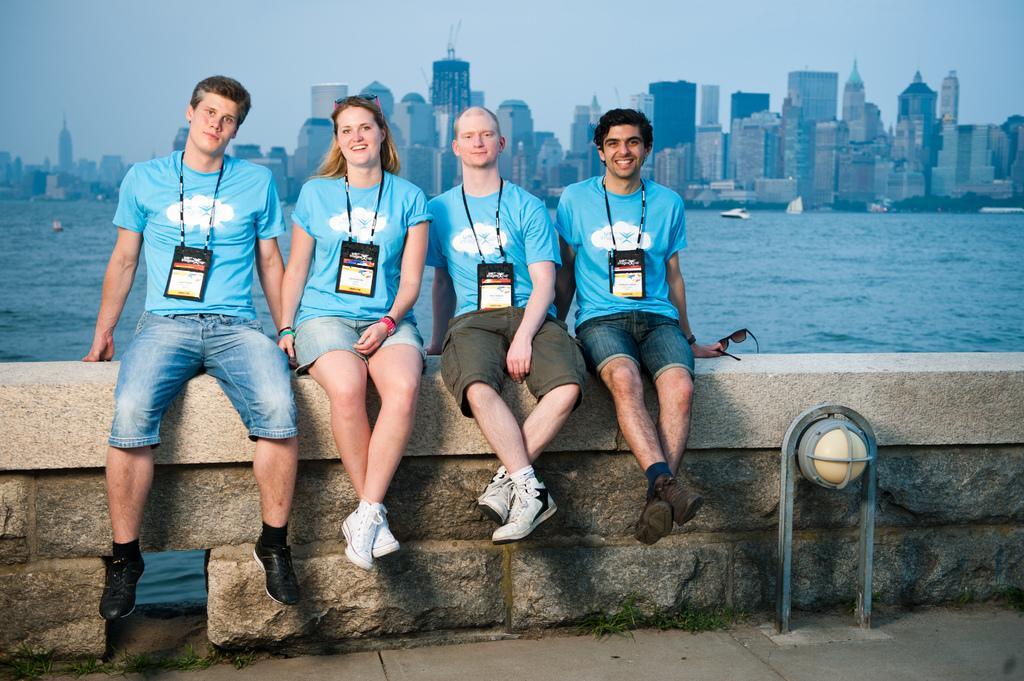Could you give a brief overview of what you see in this image? This picture describes about group of people, they are all seated and they wore tags, in front of them we can see a light and few metal rods, behind them we can find water and few buildings. 